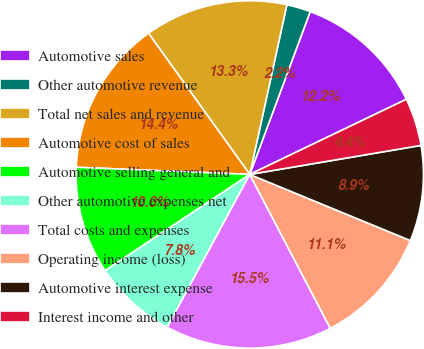<chart> <loc_0><loc_0><loc_500><loc_500><pie_chart><fcel>Automotive sales<fcel>Other automotive revenue<fcel>Total net sales and revenue<fcel>Automotive cost of sales<fcel>Automotive selling general and<fcel>Other automotive expenses net<fcel>Total costs and expenses<fcel>Operating income (loss)<fcel>Automotive interest expense<fcel>Interest income and other<nl><fcel>12.22%<fcel>2.23%<fcel>13.33%<fcel>14.44%<fcel>10.0%<fcel>7.78%<fcel>15.55%<fcel>11.11%<fcel>8.89%<fcel>4.45%<nl></chart> 